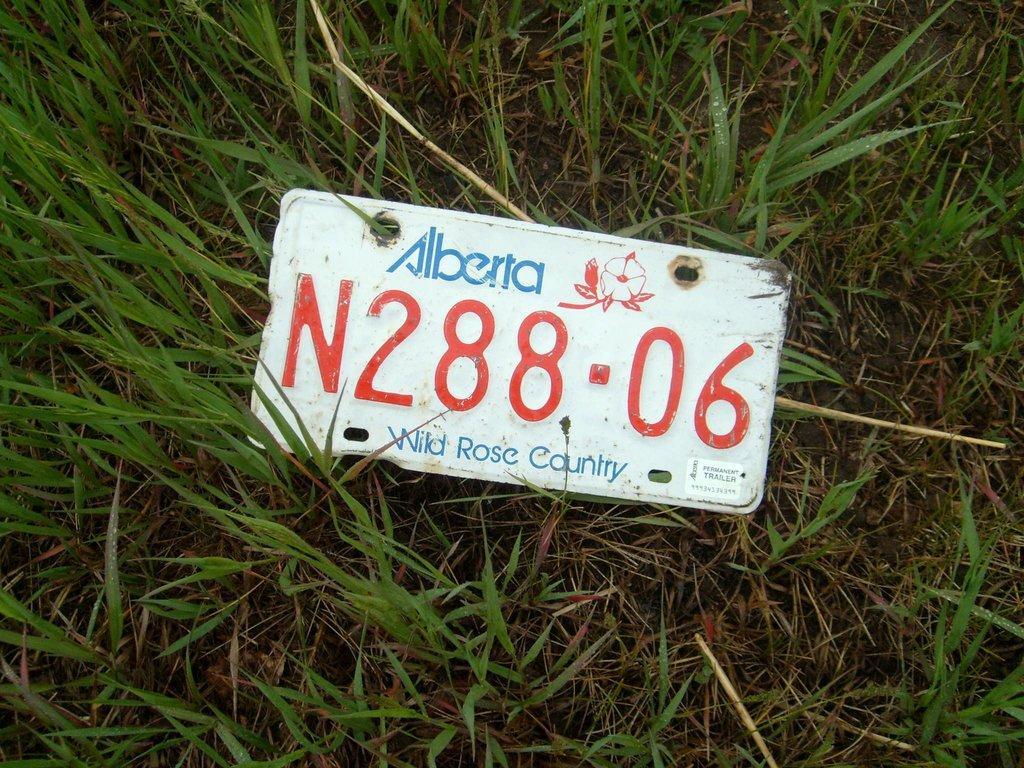In one or two sentences, can you explain what this image depicts? In this image in the front there is a board with some text written on it and there is grass on the ground. 